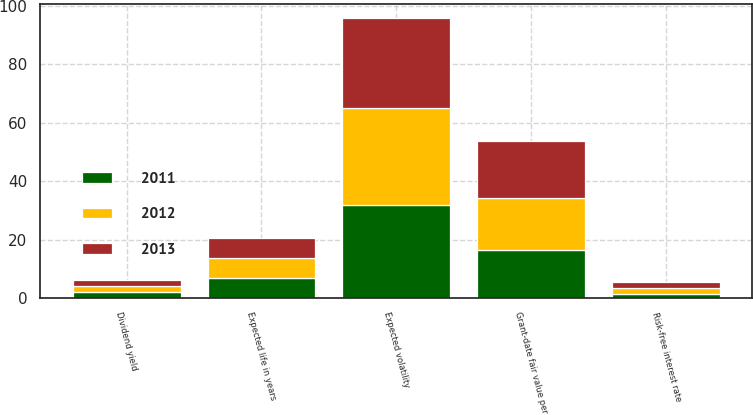Convert chart. <chart><loc_0><loc_0><loc_500><loc_500><stacked_bar_chart><ecel><fcel>Grant-date fair value per<fcel>Expected life in years<fcel>Expected volatility<fcel>Dividend yield<fcel>Risk-free interest rate<nl><fcel>2012<fcel>17.94<fcel>6.9<fcel>33<fcel>1.9<fcel>2.2<nl><fcel>2011<fcel>16.27<fcel>6.8<fcel>32<fcel>2.1<fcel>1.3<nl><fcel>2013<fcel>19.56<fcel>7<fcel>31<fcel>2.1<fcel>1.9<nl></chart> 